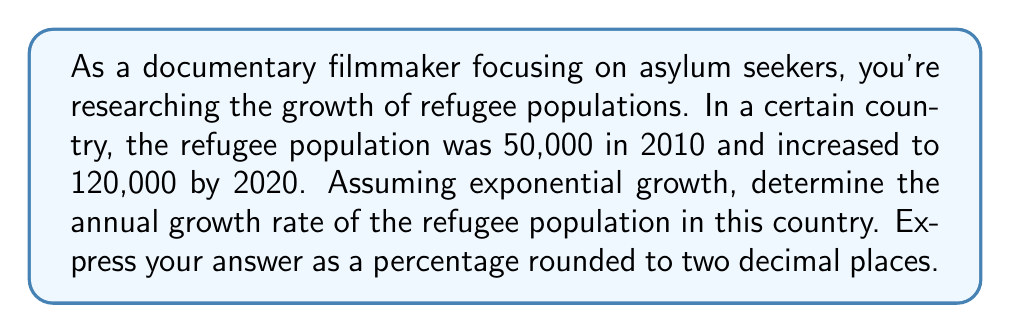Provide a solution to this math problem. To solve this problem, we'll use the exponential growth formula:

$$A = P(1 + r)^t$$

Where:
$A$ = Final amount
$P$ = Initial amount
$r$ = Annual growth rate (in decimal form)
$t$ = Time period (in years)

Given:
$P = 50,000$ (initial population in 2010)
$A = 120,000$ (final population in 2020)
$t = 10$ years

Step 1: Plug the known values into the formula.
$$120,000 = 50,000(1 + r)^{10}$$

Step 2: Divide both sides by 50,000.
$$\frac{120,000}{50,000} = (1 + r)^{10}$$
$$2.4 = (1 + r)^{10}$$

Step 3: Take the 10th root of both sides.
$$\sqrt[10]{2.4} = 1 + r$$

Step 4: Subtract 1 from both sides.
$$\sqrt[10]{2.4} - 1 = r$$

Step 5: Calculate the value of $r$.
$$r \approx 0.0916$$

Step 6: Convert to a percentage by multiplying by 100.
$$0.0916 \times 100 \approx 9.16\%$$

Therefore, the annual growth rate is approximately 9.16%.
Answer: 9.16% 